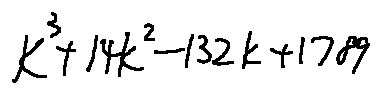Convert formula to latex. <formula><loc_0><loc_0><loc_500><loc_500>k ^ { 3 } + 1 4 k ^ { 2 } - 1 3 2 k + 1 7 8 9</formula> 